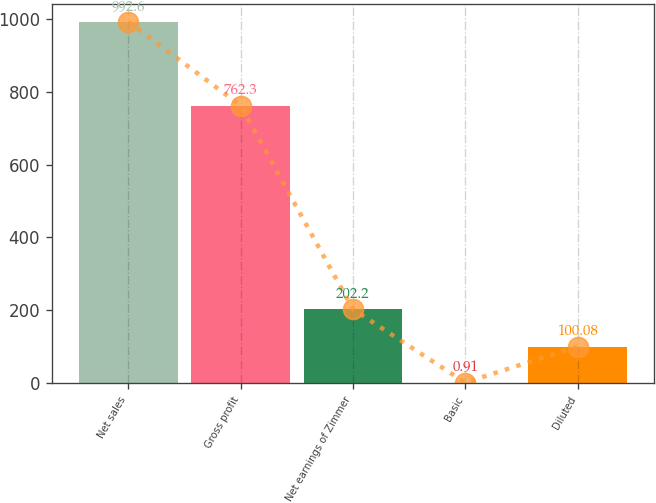Convert chart. <chart><loc_0><loc_0><loc_500><loc_500><bar_chart><fcel>Net sales<fcel>Gross profit<fcel>Net earnings of Zimmer<fcel>Basic<fcel>Diluted<nl><fcel>992.6<fcel>762.3<fcel>202.2<fcel>0.91<fcel>100.08<nl></chart> 